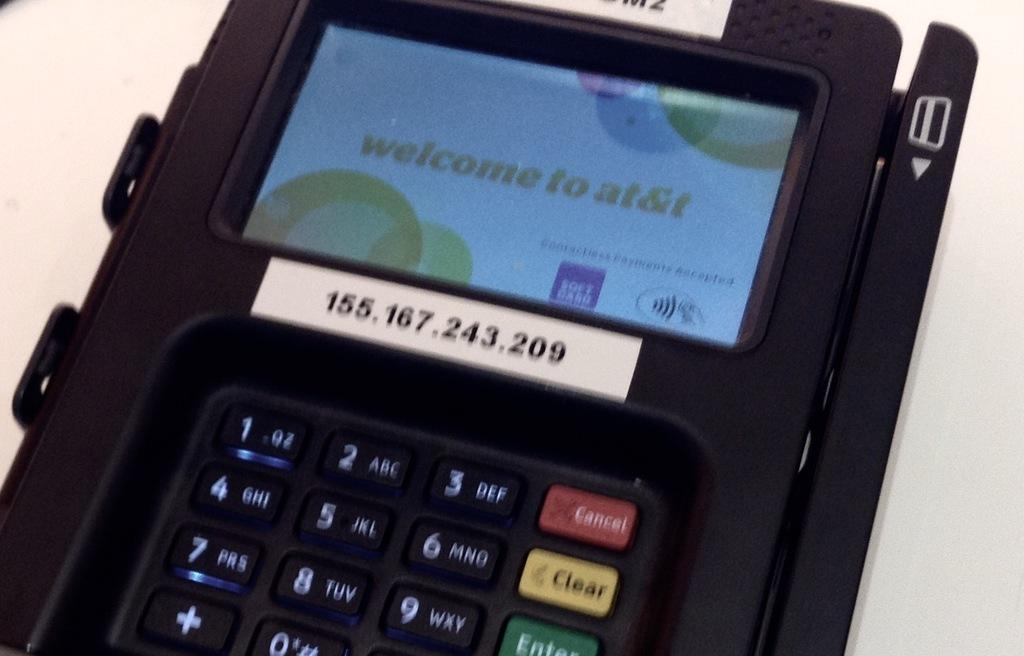Provide a one-sentence caption for the provided image. A credit card reader with a welcome to at&t sign on the screen. 